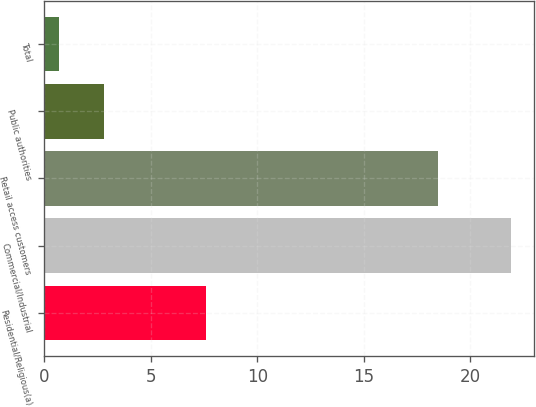Convert chart. <chart><loc_0><loc_0><loc_500><loc_500><bar_chart><fcel>Residential/Religious(a)<fcel>Commercial/Industrial<fcel>Retail access customers<fcel>Public authorities<fcel>Total<nl><fcel>7.6<fcel>21.9<fcel>18.5<fcel>2.82<fcel>0.7<nl></chart> 